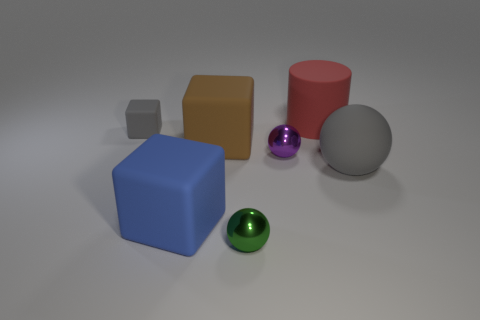Subtract all big matte cubes. How many cubes are left? 1 Add 2 big gray cubes. How many objects exist? 9 Subtract all balls. How many objects are left? 4 Add 7 tiny metal objects. How many tiny metal objects are left? 9 Add 4 gray blocks. How many gray blocks exist? 5 Subtract 0 purple cylinders. How many objects are left? 7 Subtract all blue balls. Subtract all red cylinders. How many balls are left? 3 Subtract all brown metallic cubes. Subtract all large brown blocks. How many objects are left? 6 